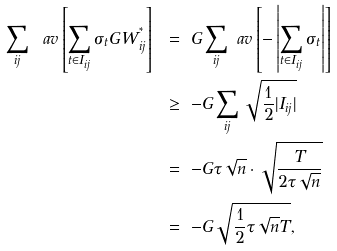<formula> <loc_0><loc_0><loc_500><loc_500>\sum _ { i j } \ a v \left [ \sum _ { t \in I _ { i j } } \sigma _ { t } G W ^ { ^ { * } } _ { i j } \right ] \ & = \ G \sum _ { i j } \ a v \left [ - \left | \sum _ { t \in I _ { i j } } \sigma _ { t } \right | \right ] \\ & \geq \ - G \sum _ { i j } \sqrt { \frac { 1 } { 2 } | I _ { i j } | } \\ & = \ - G \tau \sqrt { n } \cdot \sqrt { \frac { T } { 2 \tau \sqrt { n } } } \\ & = \ - G \sqrt { \frac { 1 } { 2 } \tau \sqrt { n } T } ,</formula> 